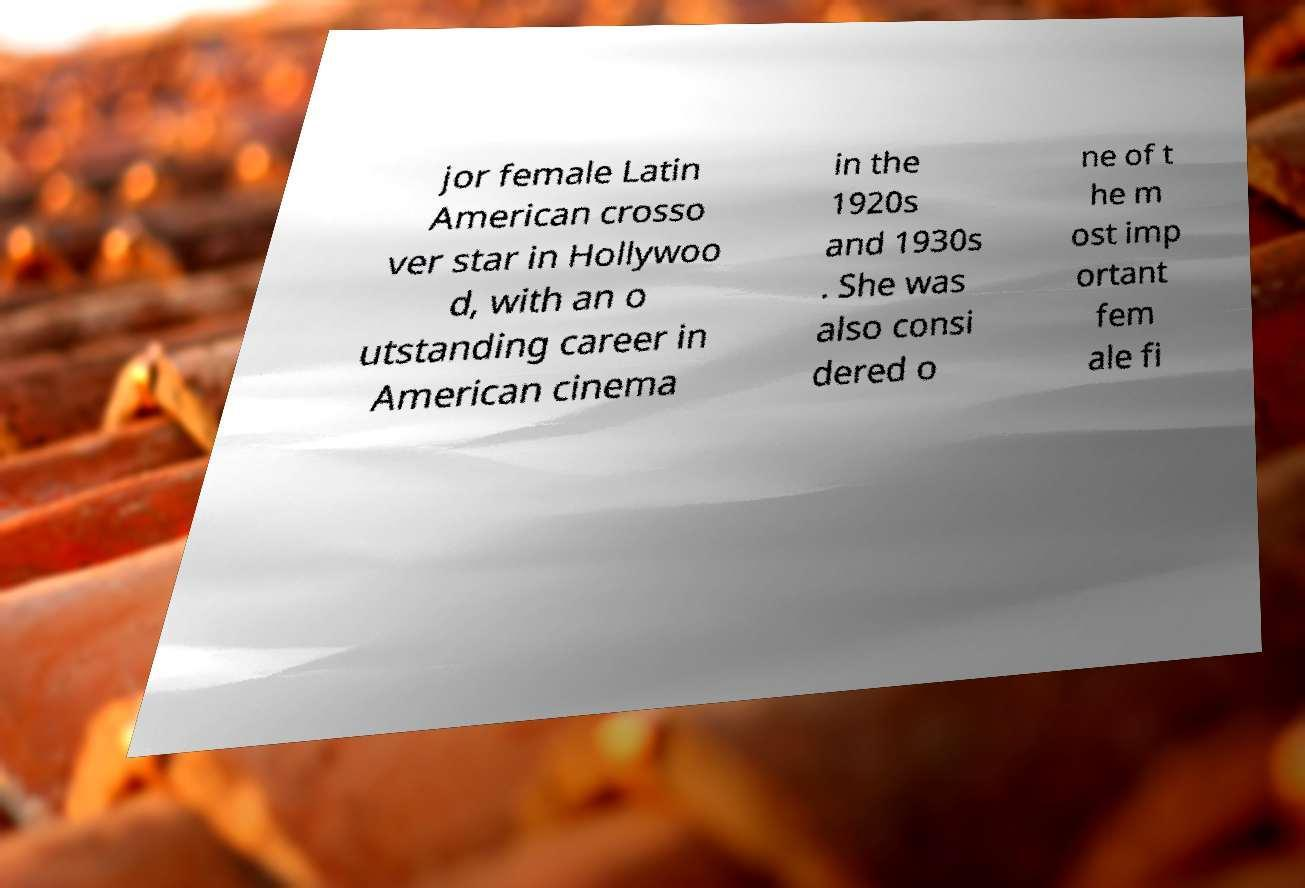For documentation purposes, I need the text within this image transcribed. Could you provide that? jor female Latin American crosso ver star in Hollywoo d, with an o utstanding career in American cinema in the 1920s and 1930s . She was also consi dered o ne of t he m ost imp ortant fem ale fi 